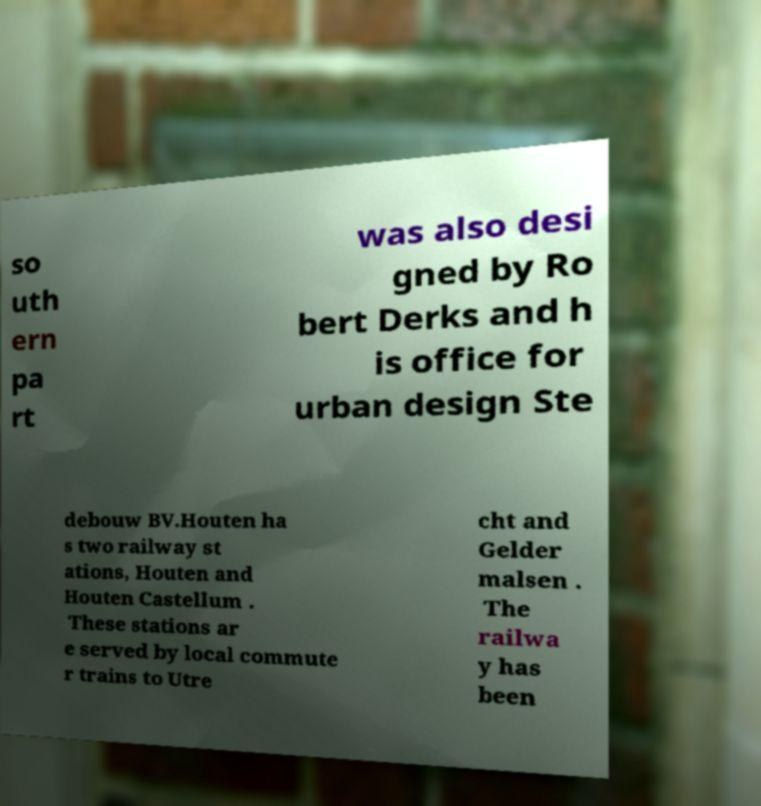Please read and relay the text visible in this image. What does it say? so uth ern pa rt was also desi gned by Ro bert Derks and h is office for urban design Ste debouw BV.Houten ha s two railway st ations, Houten and Houten Castellum . These stations ar e served by local commute r trains to Utre cht and Gelder malsen . The railwa y has been 